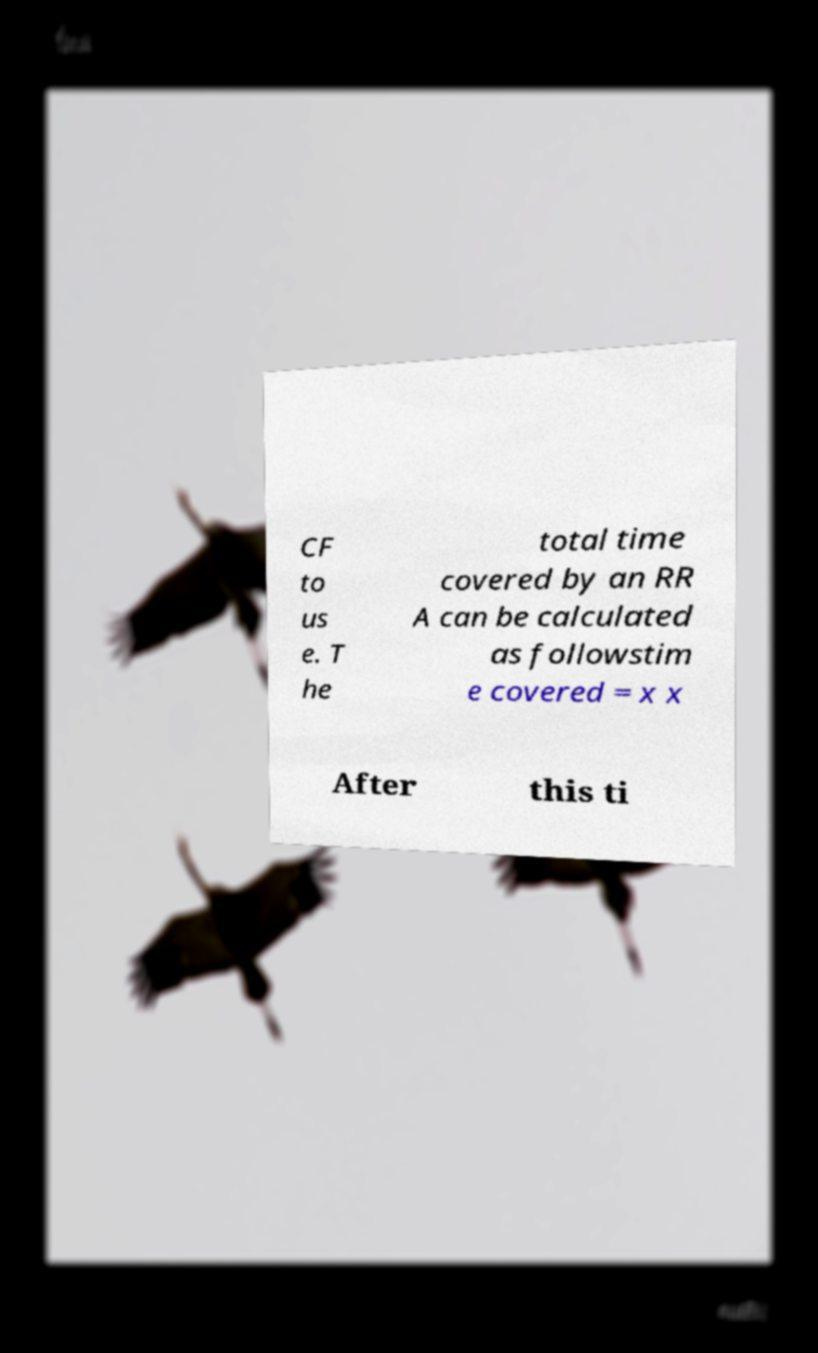Could you extract and type out the text from this image? CF to us e. T he total time covered by an RR A can be calculated as followstim e covered = x x After this ti 